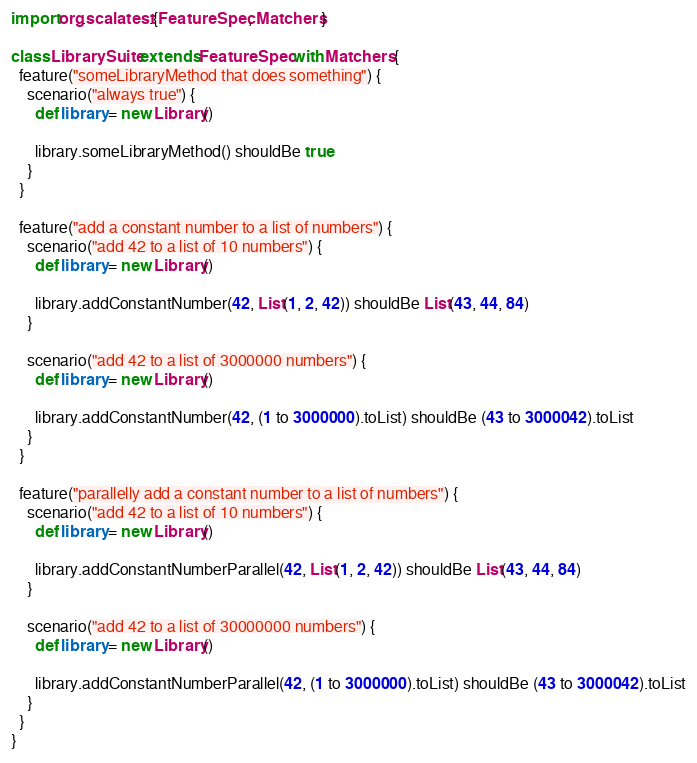<code> <loc_0><loc_0><loc_500><loc_500><_Scala_>import org.scalatest.{FeatureSpec, Matchers}

class LibrarySuite extends FeatureSpec with Matchers {
  feature("someLibraryMethod that does something") {
    scenario("always true") {
      def library = new Library()

      library.someLibraryMethod() shouldBe true
    }
  }

  feature("add a constant number to a list of numbers") {
    scenario("add 42 to a list of 10 numbers") {
      def library = new Library()

      library.addConstantNumber(42, List(1, 2, 42)) shouldBe List(43, 44, 84)
    }

    scenario("add 42 to a list of 3000000 numbers") {
      def library = new Library()

      library.addConstantNumber(42, (1 to 3000000).toList) shouldBe (43 to 3000042).toList
    }
  }

  feature("parallelly add a constant number to a list of numbers") {
    scenario("add 42 to a list of 10 numbers") {
      def library = new Library()

      library.addConstantNumberParallel(42, List(1, 2, 42)) shouldBe List(43, 44, 84)
    }

    scenario("add 42 to a list of 30000000 numbers") {
      def library = new Library()

      library.addConstantNumberParallel(42, (1 to 3000000).toList) shouldBe (43 to 3000042).toList
    }
  }
}
</code> 